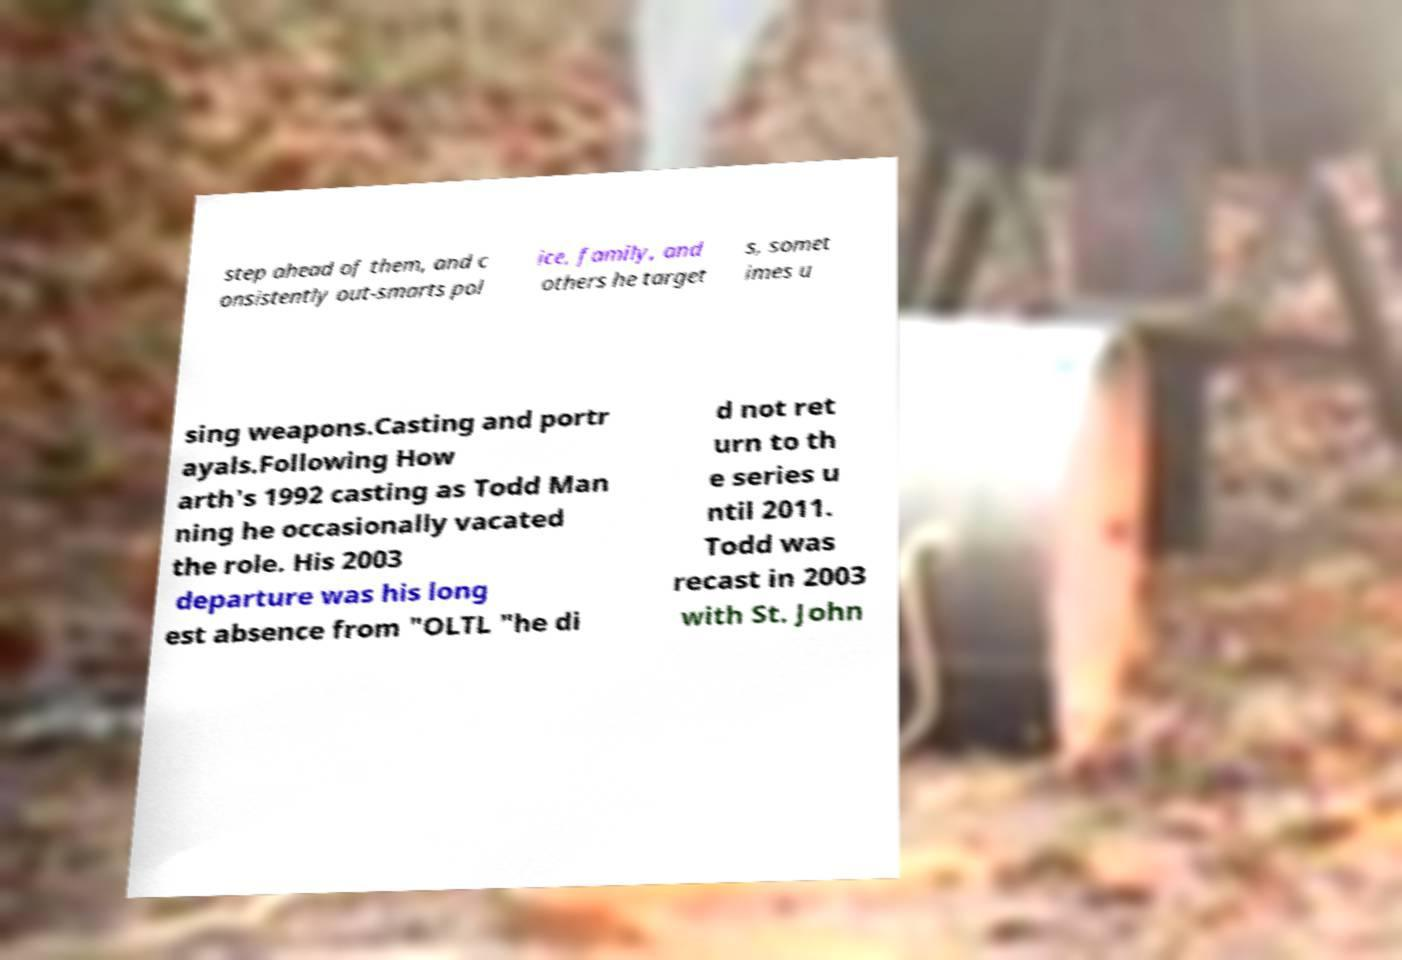Can you accurately transcribe the text from the provided image for me? step ahead of them, and c onsistently out-smarts pol ice, family, and others he target s, somet imes u sing weapons.Casting and portr ayals.Following How arth's 1992 casting as Todd Man ning he occasionally vacated the role. His 2003 departure was his long est absence from "OLTL "he di d not ret urn to th e series u ntil 2011. Todd was recast in 2003 with St. John 